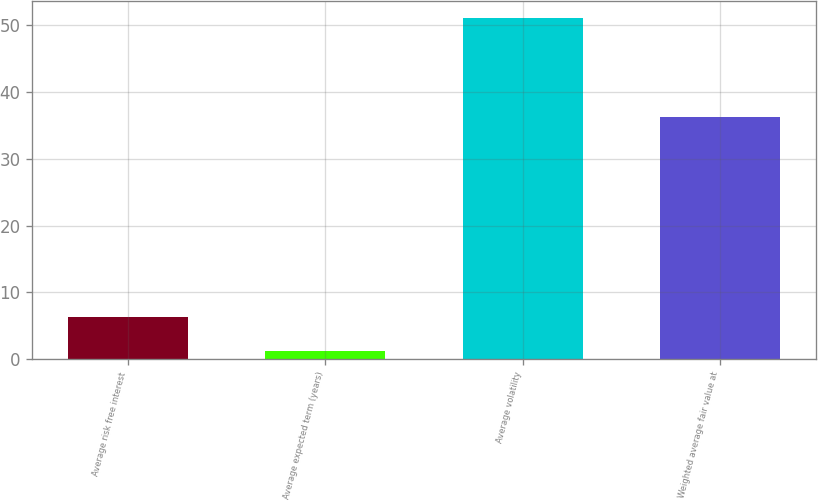<chart> <loc_0><loc_0><loc_500><loc_500><bar_chart><fcel>Average risk free interest<fcel>Average expected term (years)<fcel>Average volatility<fcel>Weighted average fair value at<nl><fcel>6.27<fcel>1.3<fcel>51<fcel>36.28<nl></chart> 